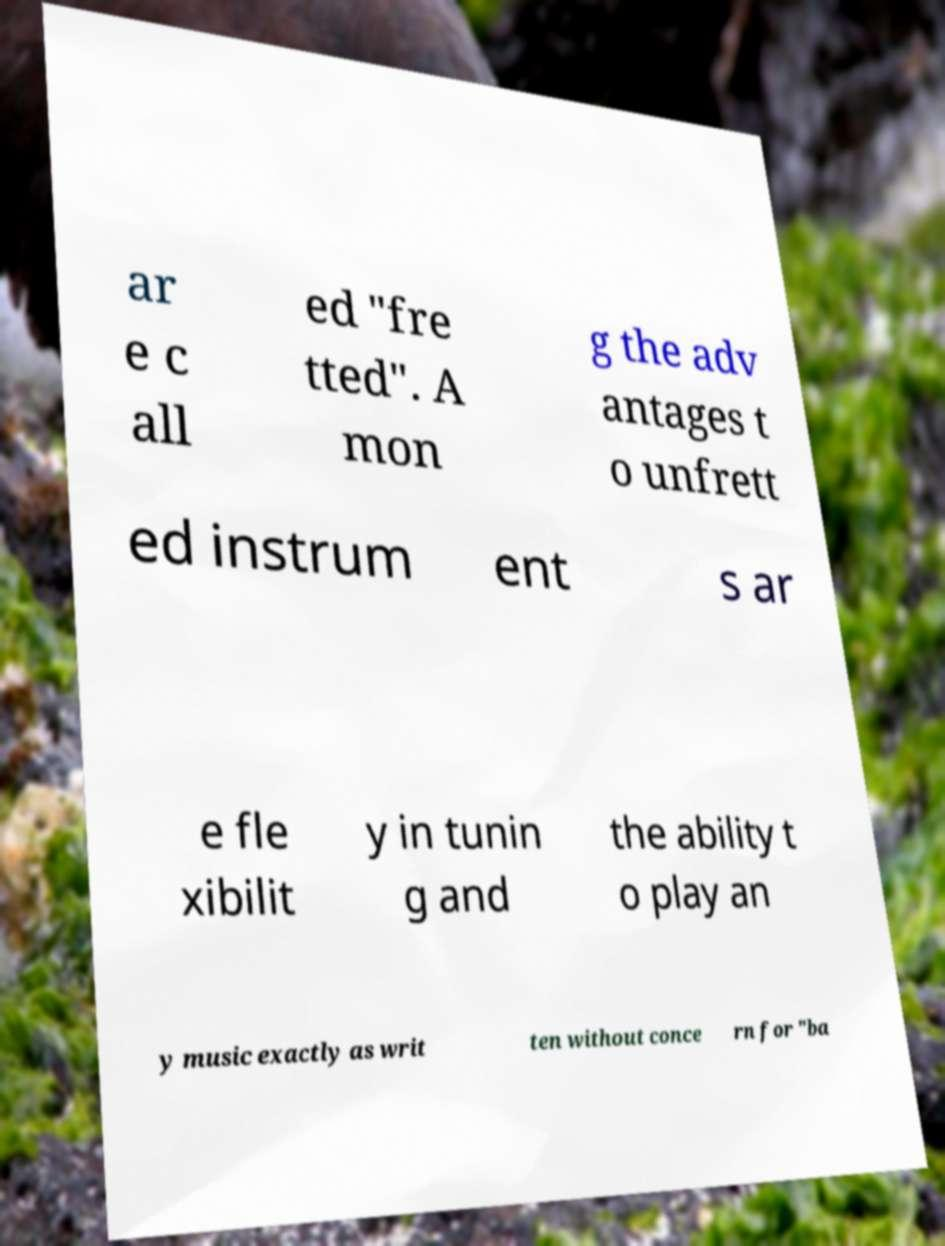Please read and relay the text visible in this image. What does it say? ar e c all ed "fre tted". A mon g the adv antages t o unfrett ed instrum ent s ar e fle xibilit y in tunin g and the ability t o play an y music exactly as writ ten without conce rn for "ba 